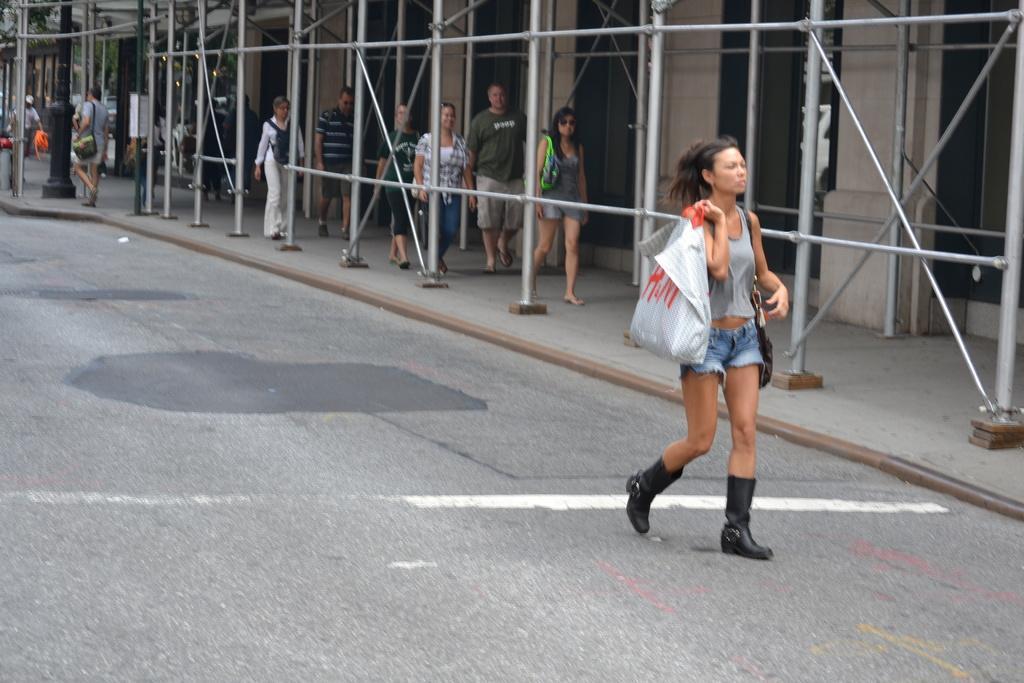How would you summarize this image in a sentence or two? In this image we can see a woman walking on the road. She is carrying a handbag and here we can see a plastic bag on her right hand. Here we can see a few persons walking on the side of the road and they are carrying the bags. Here we can see the metal pillars on the side of the road. 